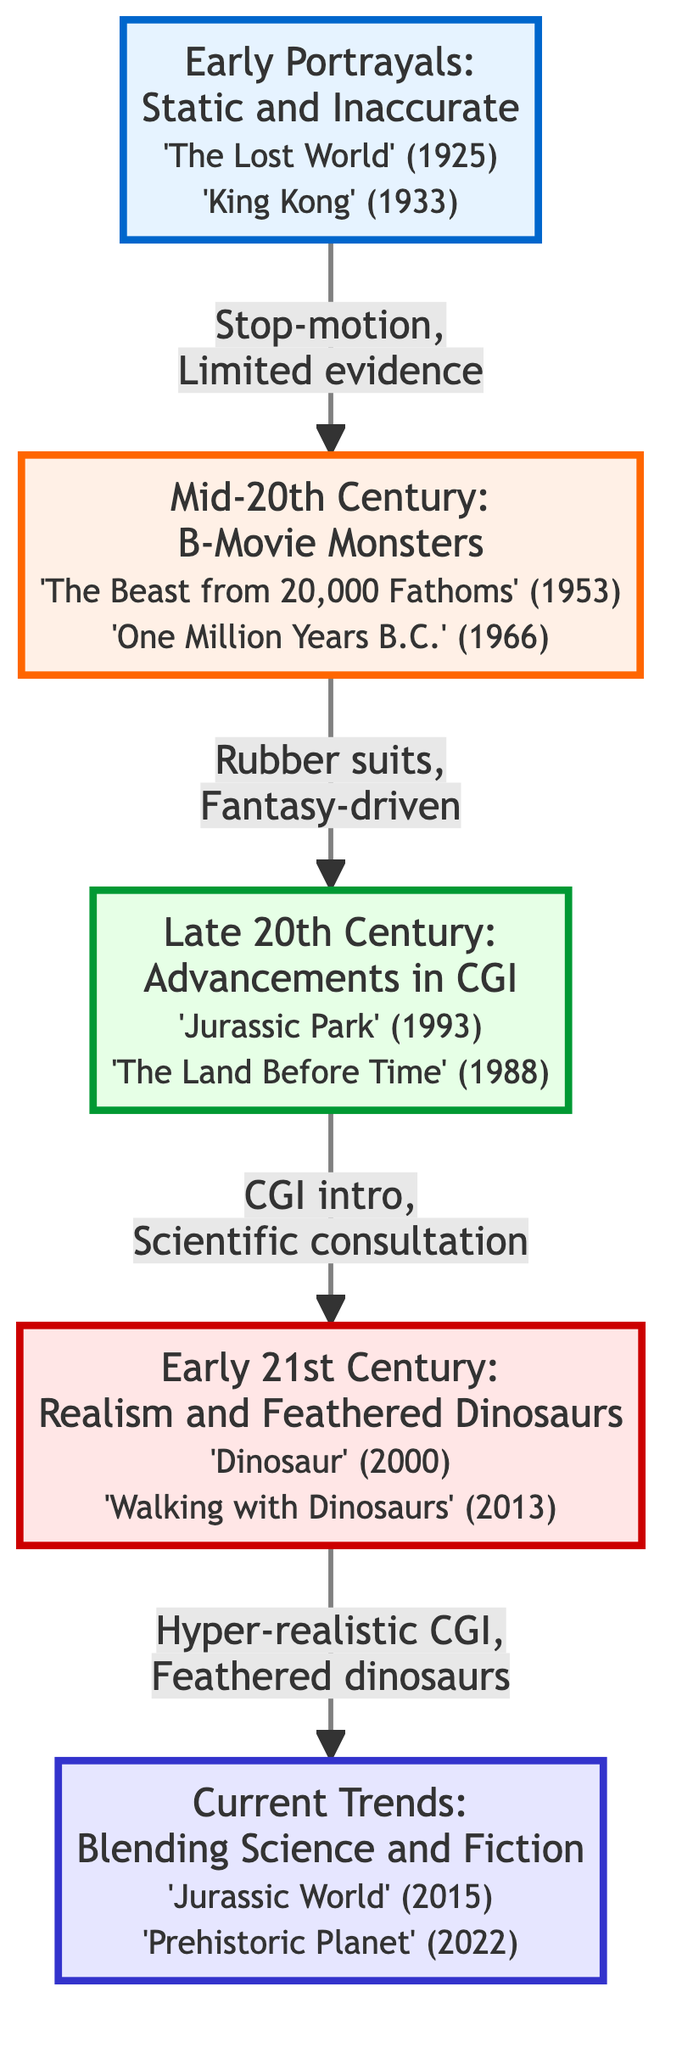What is the title of the highest node in the flow chart? The highest node in the flow chart is labeled "Current Trends: Blending Science and Fiction." This can be determined by identifying the node that is placed at the top position in the diagram.
Answer: Current Trends: Blending Science and Fiction Which movie is associated with the level 3 node? The level 3 node is titled "Late 20th Century: Advancements in CGI." The key movies listed under this node are "Jurassic Park (1993)" and "The Land Before Time (1988)." Therefore, either of these movies is associated with the level 3 node.
Answer: Jurassic Park (1993) How many total levels are present in the diagram? The diagram contains a total of 5 levels, which can be counted directly from the distinct sections represented, starting from level 1 at the bottom to level 5 at the top.
Answer: 5 What characteristic connects level 2 to level 3? The characteristic that connects level 2 ("Mid-20th Century: B-Movie Monsters") to level 3 ("Late 20th Century: Advancements in CGI") is summarized as "Rubber suits, Fantasy-driven." This is indicated on the arrow that leads from level 2 to level 3 in the flow chart.
Answer: Rubber suits, Fantasy-driven What is the relationship between the "Early 21st Century" and "Current Trends" nodes? The "Early 21st Century: Realism and Feathered Dinosaurs" node is directly connected to the "Current Trends: Blending Science and Fiction" node. The characteristic noted on their connection is "Hyper-realistic CGI, Feathered dinosaurs," which suggests a progression and relationship in the evolution of dinosaur depictions between these two levels.
Answer: Hyper-realistic CGI, Feathered dinosaurs What is a key characteristic from the level 1 node? The level 1 node is titled "Early Portrayals: Static and Inaccurate" and includes key characteristics such as "Stop-motion animation," "Depictions based on limited fossil evidence," and "Scientific inaccuracies in dinosaur behavior and anatomy." Any of these characteristics could be considered a key characteristic.
Answer: Stop-motion animation Which two movies are featured in the level 4 node? The level 4 node is labeled "Early 21st Century: Realism and Feathered Dinosaurs," which includes the movies "Dinosaur (2000)" and "Walking with Dinosaurs (2013)." Therefore, either movie is part of level 4.
Answer: Dinosaur (2000) What defines the transition from level 3 to level 4 in the flow chart? The transition from level 3 ("Late 20th Century: Advancements in CGI") to level 4 ("Early 21st Century: Realism and Feathered Dinosaurs") is defined by the characteristic "CGI intro, Scientific consultation." This defines the advancement in techniques and accuracies in dinosaur depictions at this level.
Answer: CGI intro, Scientific consultation 